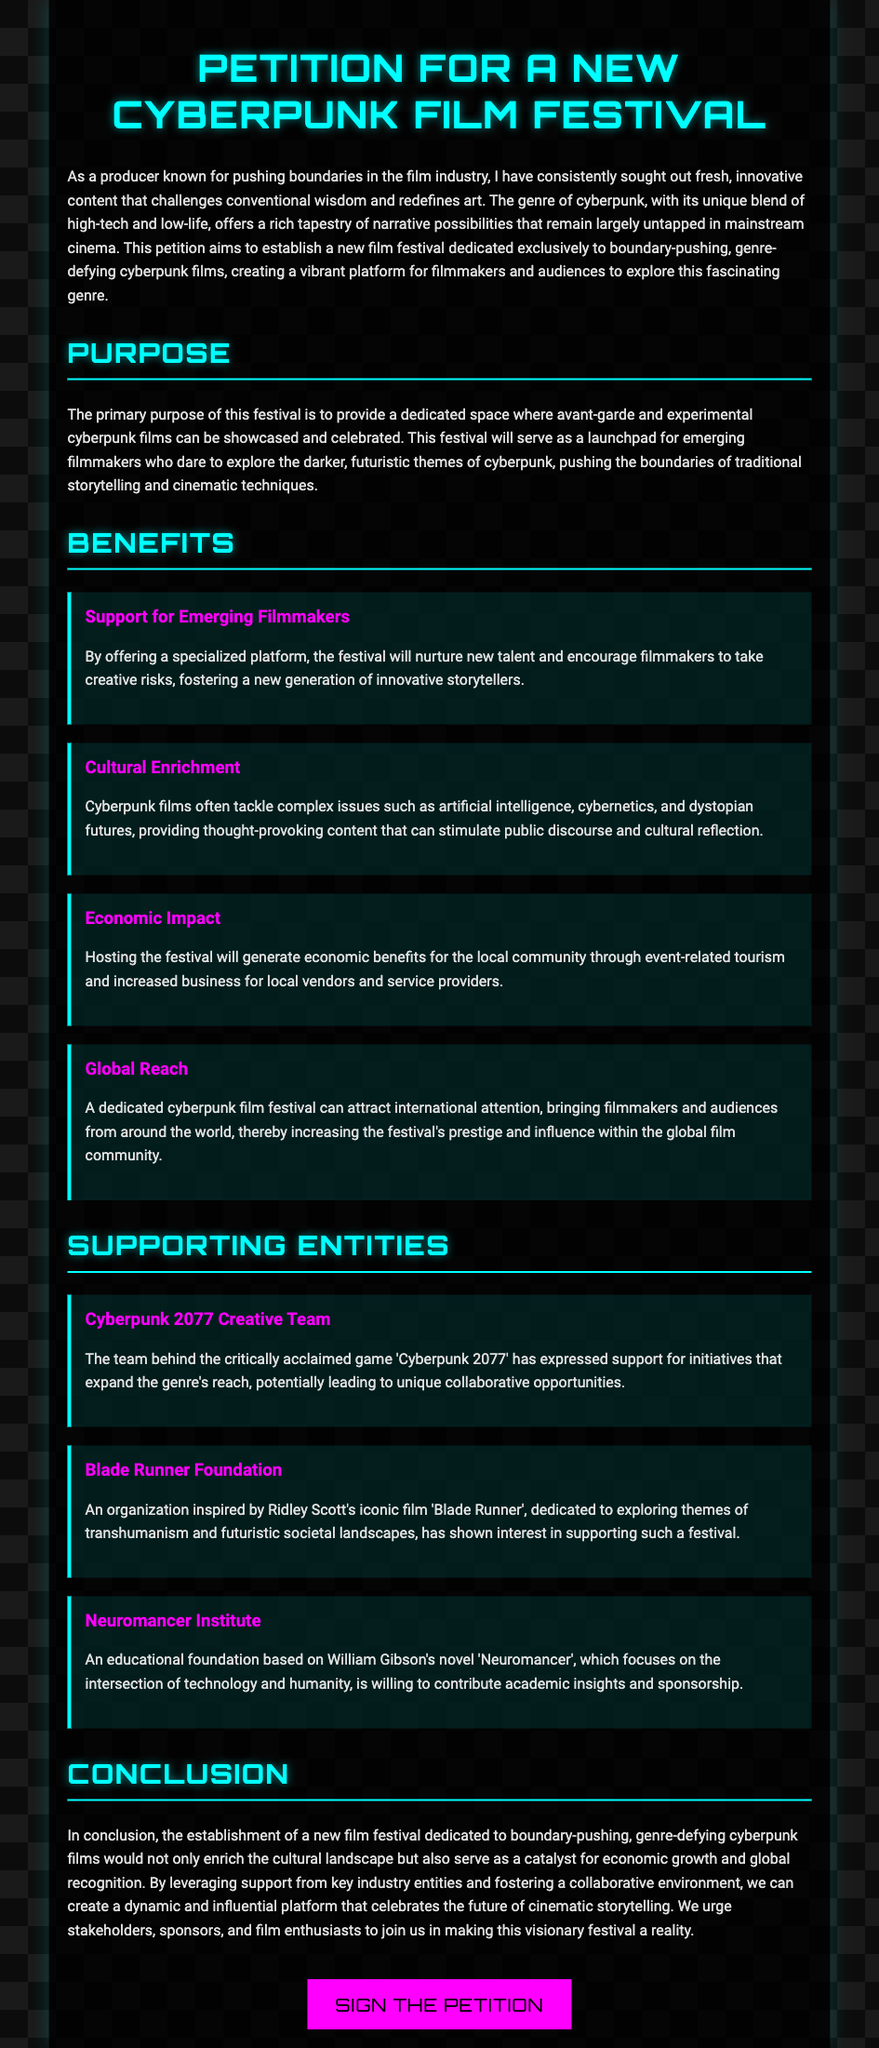What is the title of the petition? The title of the petition is located at the top of the document.
Answer: Petition for a New Cyberpunk Film Festival What is the main purpose of the festival? The main purpose of the festival is outlined in a specific section discussing its objectives.
Answer: To provide a dedicated space for avant-garde and experimental cyberpunk films How many benefits are listed in the document? The document enumerates various benefits in a dedicated section.
Answer: Four Which entity is associated with 'Neuromancer'? The specific entity associated with 'Neuromancer' is mentioned in the section discussing supporting entities.
Answer: Neuromancer Institute What color is used for the festival title? The color used for the festival title is mentioned in the styling section of the document.
Answer: #00ffff What will hosting the festival generate for the local community? This effect is mentioned in the economic impact benefit of the festival.
Answer: Economic benefits Which foundation is inspired by 'Blade Runner'? The foundation related to 'Blade Runner' is specified in the supporting entities section.
Answer: Blade Runner Foundation What genre of films will the festival focus on? The specific genre of films targeted by the festival is stated early in the document.
Answer: Cyberpunk What button is available for signing the petition? The button's purpose is described in the closing section of the document.
Answer: Sign the Petition 